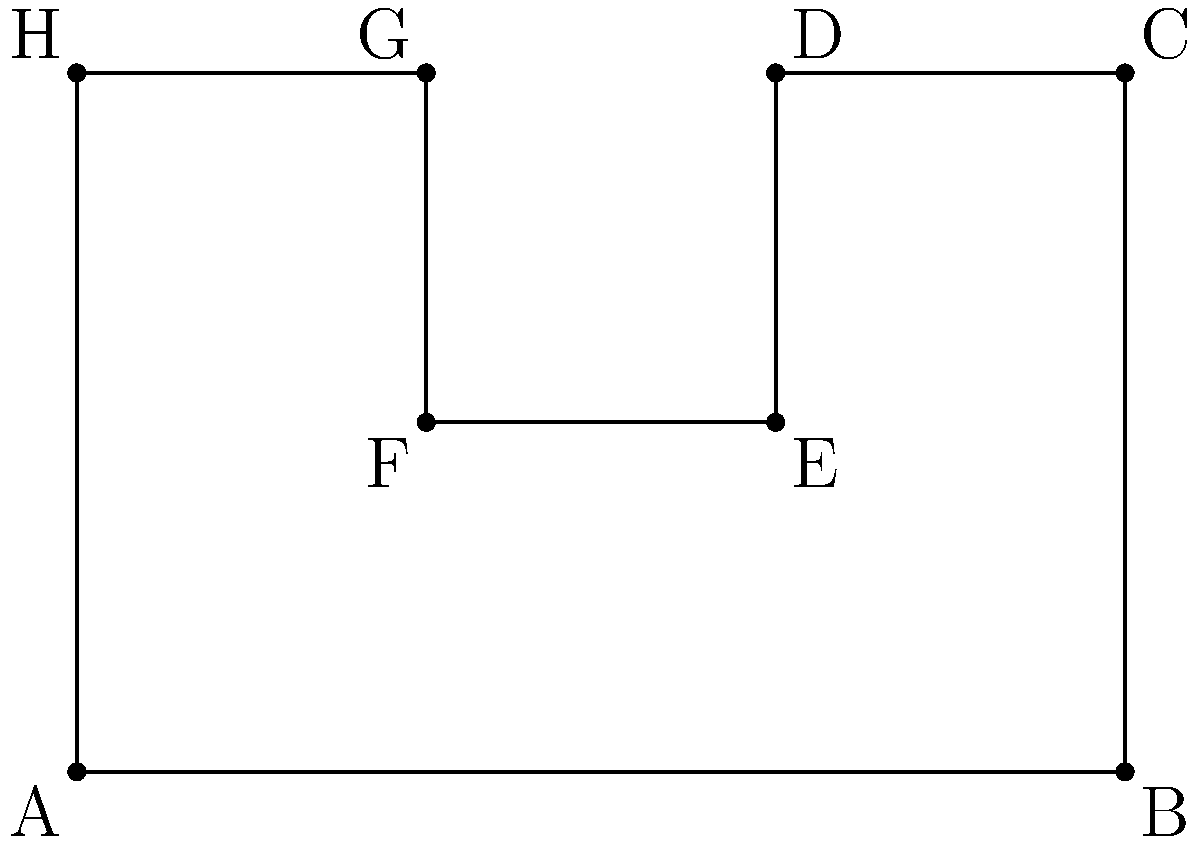You have an oddly-shaped baking dish that resembles a modified rectangle. The shape of the dish can be represented on a coordinate plane as shown in the figure above. Calculate the area of this baking dish using coordinate geometry. All measurements are in inches. To calculate the area of this oddly-shaped baking dish, we can break it down into rectangles and subtract the area of the "cutout" from the larger rectangle. Let's approach this step-by-step:

1) First, let's identify the main rectangle:
   It spans from (0,0) to (6,4), so its area is:
   $A_1 = 6 \times 4 = 24$ square inches

2) Now, let's identify the "cutout" rectangle:
   It spans from (2,2) to (4,4), so its area is:
   $A_2 = 2 \times 2 = 4$ square inches

3) The area of our baking dish will be the difference between these two areas:
   $A_{total} = A_1 - A_2 = 24 - 4 = 20$ square inches

We can verify this by breaking the shape into three rectangles:

a) Rectangle from (0,0) to (6,2): $6 \times 2 = 12$ sq in
b) Rectangle from (0,2) to (2,4): $2 \times 2 = 4$ sq in
c) Rectangle from (4,2) to (6,4): $2 \times 2 = 4$ sq in

Adding these: $12 + 4 + 4 = 20$ square inches

Therefore, the area of the baking dish is 20 square inches.
Answer: 20 square inches 